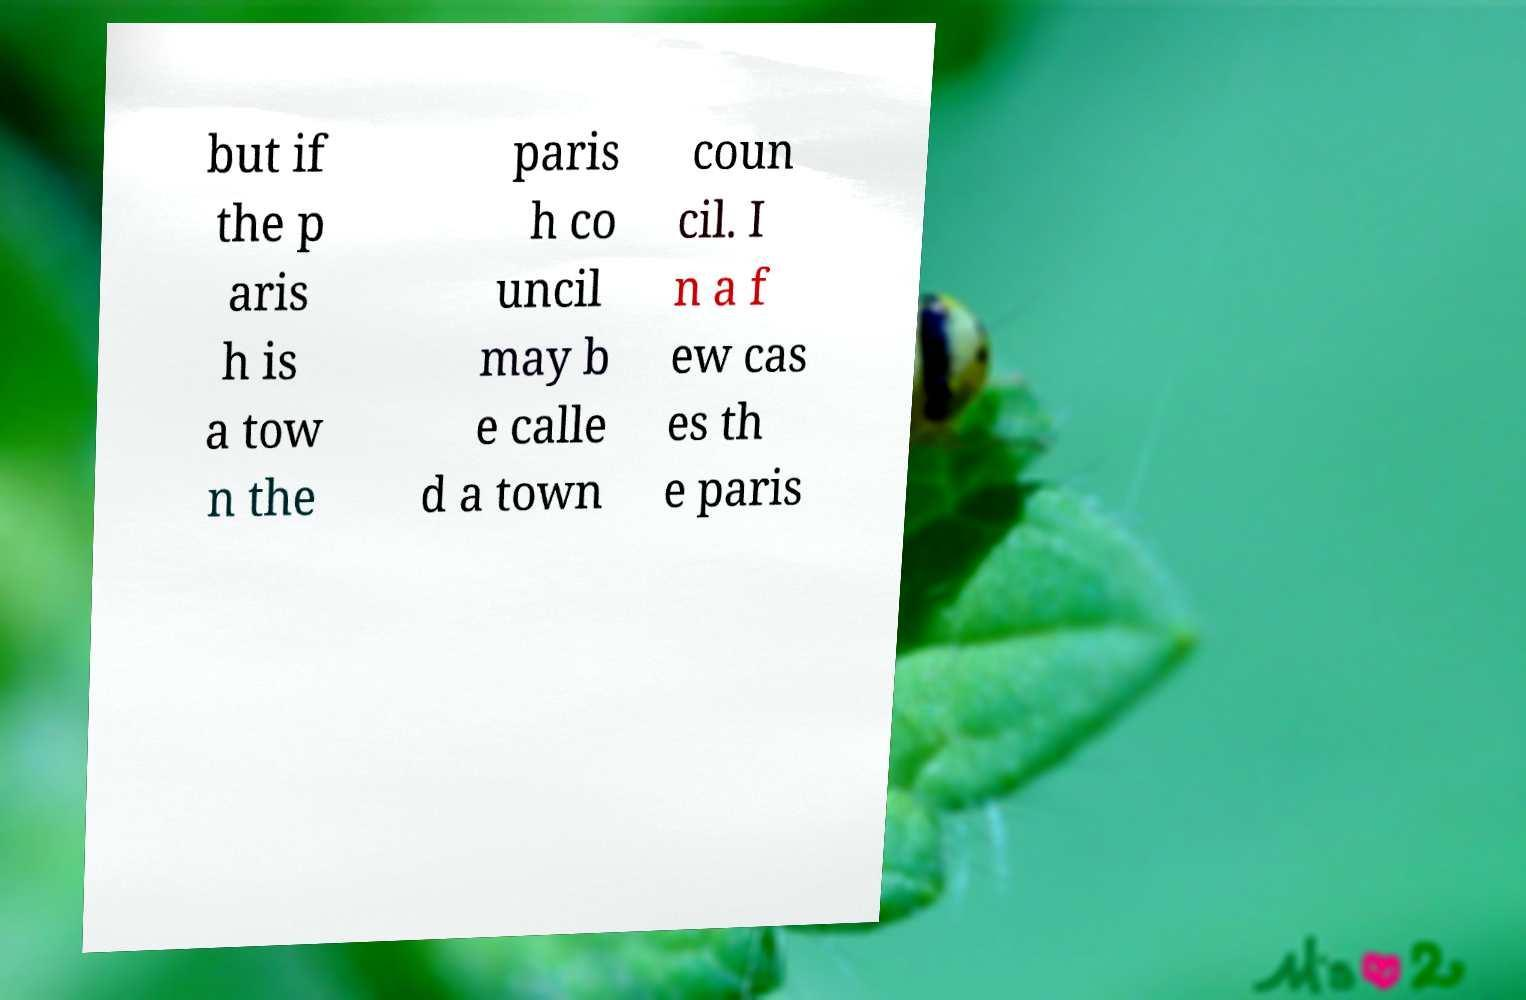I need the written content from this picture converted into text. Can you do that? but if the p aris h is a tow n the paris h co uncil may b e calle d a town coun cil. I n a f ew cas es th e paris 